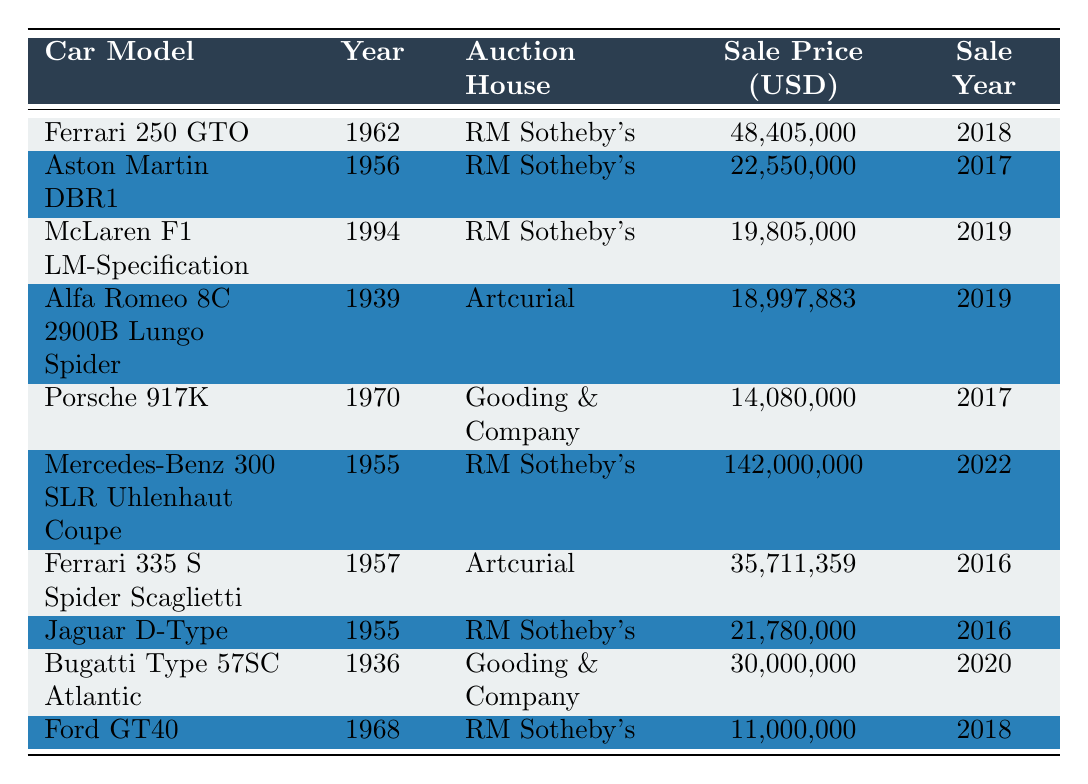What is the highest sale price recorded in the table? The highest sale price is found by scanning the "Sale Price (USD)" column for the maximum value, which is 142,000,000.
Answer: 142,000,000 Which car was sold for the lowest amount? By reviewing the "Sale Price (USD)" column, the lowest amount is 11,000,000 corresponding to the Ford GT40.
Answer: 11,000,000 How many cars were sold for more than 20 million dollars? Checking the "Sale Price (USD)" column, the cars with prices above 20 million are: Ferrari 250 GTO, Aston Martin DBR1, Ferrari 335 S Spider Scaglietti, Mercedes-Benz 300 SLR Uhlenhaut Coupe, Bugatti Type 57SC Atlantic, and Jaguar D-Type, totaling 6 cars.
Answer: 6 What is the average sale price of the cars sold in the last five years? First, we sum all the sale prices: (48,405,000 + 22,550,000 + 19,805,000 + 18,997,883 + 14,080,000 + 142,000,000 + 35,711,359 + 21,780,000 + 30,000,000 + 11,000,000) = 352,329,242. Then, we divide by the number of cars (10): 352,329,242 / 10 = 35,232,924.2.
Answer: 35,232,924.2 Which auction house sold the most valuable car? By reviewing the "Auction House" and "Sale Price (USD)" columns, we identify that the Mercedes-Benz 300 SLR Uhlenhaut Coupe was sold at RM Sotheby's for the highest price, which is 142,000,000.
Answer: RM Sotheby's Did any car models sell for exactly 30 million dollars? Reviewing the "Sale Price (USD)" column, there is one entry, the Bugatti Type 57SC Atlantic, that sold for exactly 30,000,000.
Answer: Yes How many cars sold in 2019 were listed with RM Sotheby's? Looking through both the "Sale Year" and "Auction House" columns, only the McLaren F1 LM-Specification was sold in 2019 at RM Sotheby's, resulting in a count of 1 car.
Answer: 1 What is the difference in sale price between the most expensive and the least expensive car? The most expensive is 142,000,000 (Mercedes-Benz 300 SLR Uhlenhaut Coupe) and the least expensive is 11,000,000 (Ford GT40). So, the difference is 142,000,000 - 11,000,000 = 131,000,000.
Answer: 131,000,000 Which car sold for the highest price in 2018? Scanning the "Sale Year" column for 2018 and comparing the prices, the Ferrari 250 GTO sold for 48,405,000 was the highest in that year.
Answer: Ferrari 250 GTO What percentage of the total sales were made by RM Sotheby's? First, calculate total sales: 352,329,242. RM Sotheby’s sales are 48,405,000 + 22,550,000 + 19,805,000 + 142,000,000 + 21,780,000 + 11,000,000 = 265,540,000. To calculate the percentage: (265,540,000 / 352,329,242) * 100 = 75.4%.
Answer: 75.4% 